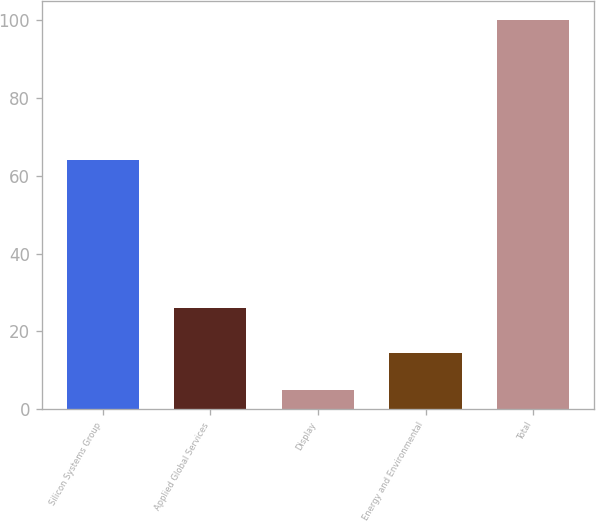Convert chart. <chart><loc_0><loc_0><loc_500><loc_500><bar_chart><fcel>Silicon Systems Group<fcel>Applied Global Services<fcel>Display<fcel>Energy and Environmental<fcel>Total<nl><fcel>64<fcel>26<fcel>5<fcel>14.5<fcel>100<nl></chart> 